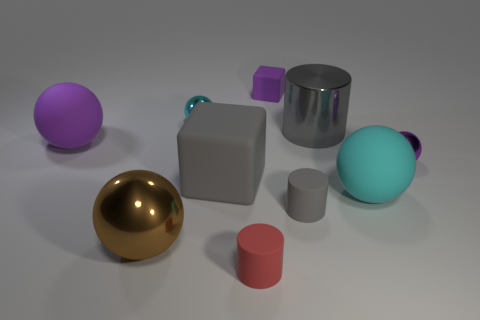Can you speculate on the setting or purpose of these objects? Certainly. The arrangement and diversity of the objects could suggest a display or a study in contrasts, perhaps for an artistic or educational purpose. The variety in color and shape, along with the neutral background, lends the scene a sort of gallery or showroom ambiance. It seems as though these objects are curated to emphasize differences in geometry and hue, possibly for a demonstration in design, color theory, or geometry. 